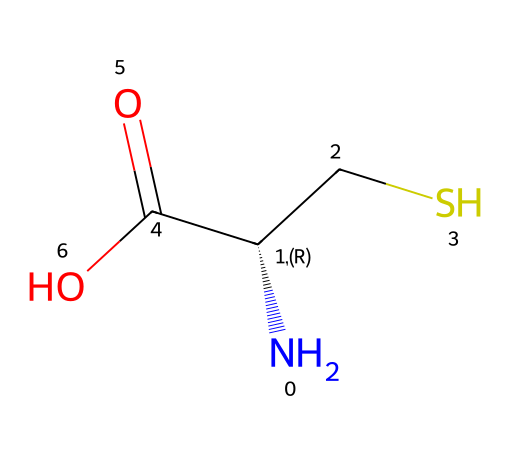What is the molecular formula of cysteine? To determine the molecular formula from the SMILES representation, identify all elements and their counts. The SMILES indicates one nitrogen (N), three carbons (C), seven hydrogens (H), two oxygens (O), and one sulfur (S). Thus, the formula is C3H7NO2S.
Answer: C3H7NO2S How many chiral centers are present in cysteine? Chiral centers occur at carbons that have four different substituents. In the provided structure, the carbon atom connected to the nitrogen (N) has four distinct groups (the amino group, carboxylic acid, sulfhydryl, and the hydrogen), making it a chiral center. There is one chiral center in cysteine.
Answer: 1 What type of bonding is primarily responsible for cysteine's ability to form disulfide bridges? The covalent bond between the sulfur atoms in cysteine is responsible for disulfide bridges. In cysteine, the thiol (-SH) group can oxidize to form a covalent bond with another cysteine (–S–S–), which is crucial for protein structure stabilization.
Answer: covalent bond What is the significance of the sulfhydryl group in cysteine regarding athletic performance? The sulfhydryl group (-SH) is critical for the formation of disulfide bonds, which impact protein structure and function, particularly in muscle proteins necessary for athletic performance. The presence of sulfur means cysteine participates in maintaining the integrity of proteins involved in muscle contraction and recovery during exercise.
Answer: protein structure How many functional groups are present in cysteine? Analyzing the SMILES representation reveals three functional groups in cysteine: an amino group (-NH2), a carboxylic acid group (-COOH), and a thiol group (-SH). These functionalities contribute to its biochemical roles. Therefore, cysteine contains three functional groups.
Answer: 3 What role does the amino group play in cysteine? The amino group (-NH2) in cysteine is basic, allowing it to accept protons and participate in peptide bond formation during protein synthesis. This is essential for the structure and function of proteins in the body, including those related to athletic performance.
Answer: peptide bond formation 